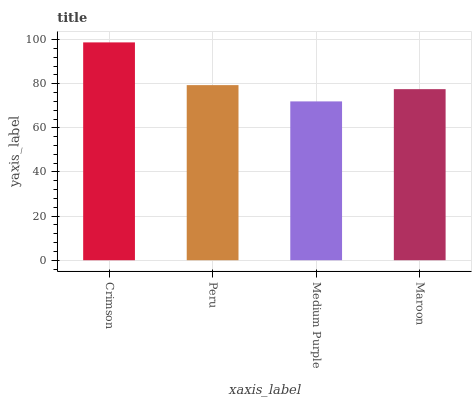Is Peru the minimum?
Answer yes or no. No. Is Peru the maximum?
Answer yes or no. No. Is Crimson greater than Peru?
Answer yes or no. Yes. Is Peru less than Crimson?
Answer yes or no. Yes. Is Peru greater than Crimson?
Answer yes or no. No. Is Crimson less than Peru?
Answer yes or no. No. Is Peru the high median?
Answer yes or no. Yes. Is Maroon the low median?
Answer yes or no. Yes. Is Crimson the high median?
Answer yes or no. No. Is Crimson the low median?
Answer yes or no. No. 